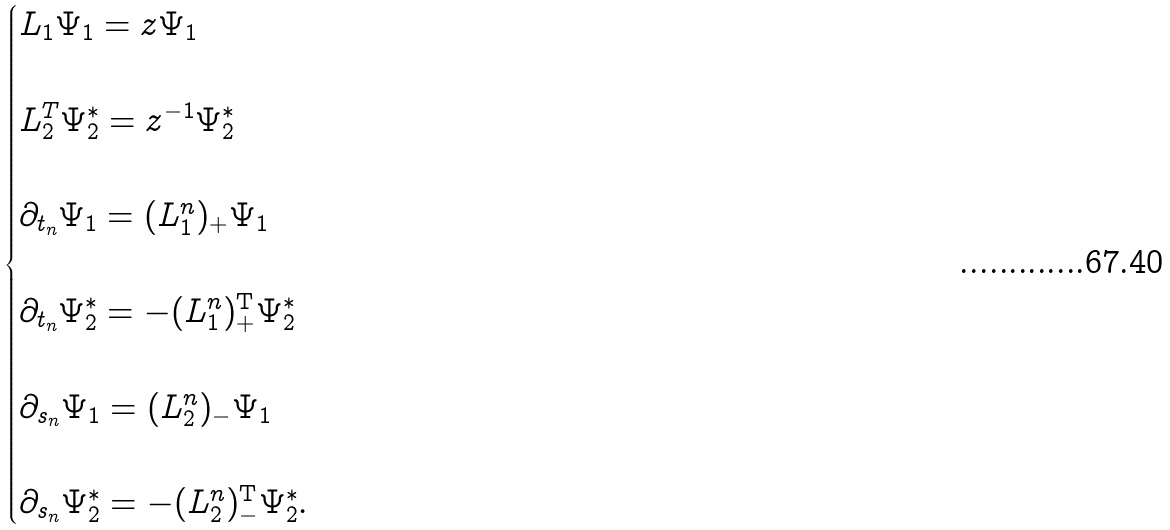<formula> <loc_0><loc_0><loc_500><loc_500>\begin{cases} L _ { 1 } \Psi _ { 1 } = z \Psi _ { 1 } \\ \\ L _ { 2 } ^ { T } \Psi ^ { * } _ { 2 } = z ^ { - 1 } \Psi ^ { * } _ { 2 } \\ \\ \partial _ { t _ { n } } \Psi _ { 1 } = ( L _ { 1 } ^ { n } ) _ { + } \Psi _ { 1 } \\ \\ \partial _ { t _ { n } } \Psi _ { 2 } ^ { * } = - ( L _ { 1 } ^ { n } ) _ { + } ^ { \mathrm T } \Psi _ { 2 } ^ { * } \\ \\ \partial _ { s _ { n } } \Psi _ { 1 } = ( L _ { 2 } ^ { n } ) _ { - } \Psi _ { 1 } \\ \\ \partial _ { s _ { n } } \Psi _ { 2 } ^ { * } = - ( L _ { 2 } ^ { n } ) _ { - } ^ { \mathrm T } \Psi _ { 2 } ^ { * } . \end{cases}</formula> 